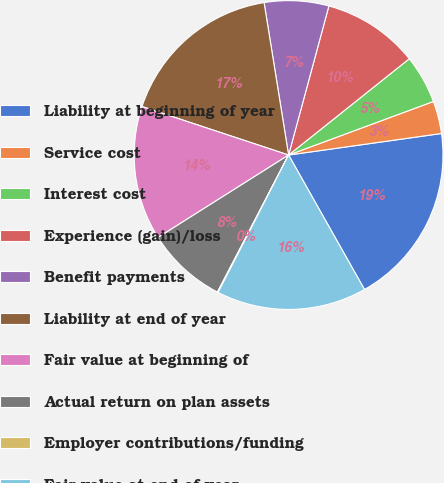Convert chart. <chart><loc_0><loc_0><loc_500><loc_500><pie_chart><fcel>Liability at beginning of year<fcel>Service cost<fcel>Interest cost<fcel>Experience (gain)/loss<fcel>Benefit payments<fcel>Liability at end of year<fcel>Fair value at beginning of<fcel>Actual return on plan assets<fcel>Employer contributions/funding<fcel>Fair value at end of year<nl><fcel>19.05%<fcel>3.41%<fcel>5.08%<fcel>10.08%<fcel>6.74%<fcel>17.38%<fcel>14.05%<fcel>8.41%<fcel>0.08%<fcel>15.72%<nl></chart> 